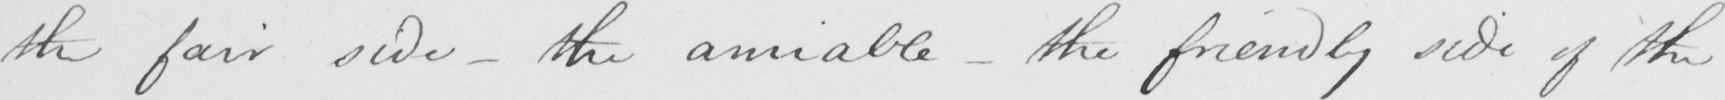Please transcribe the handwritten text in this image. the fair side  _  the amiable  _  the friendly side of the 